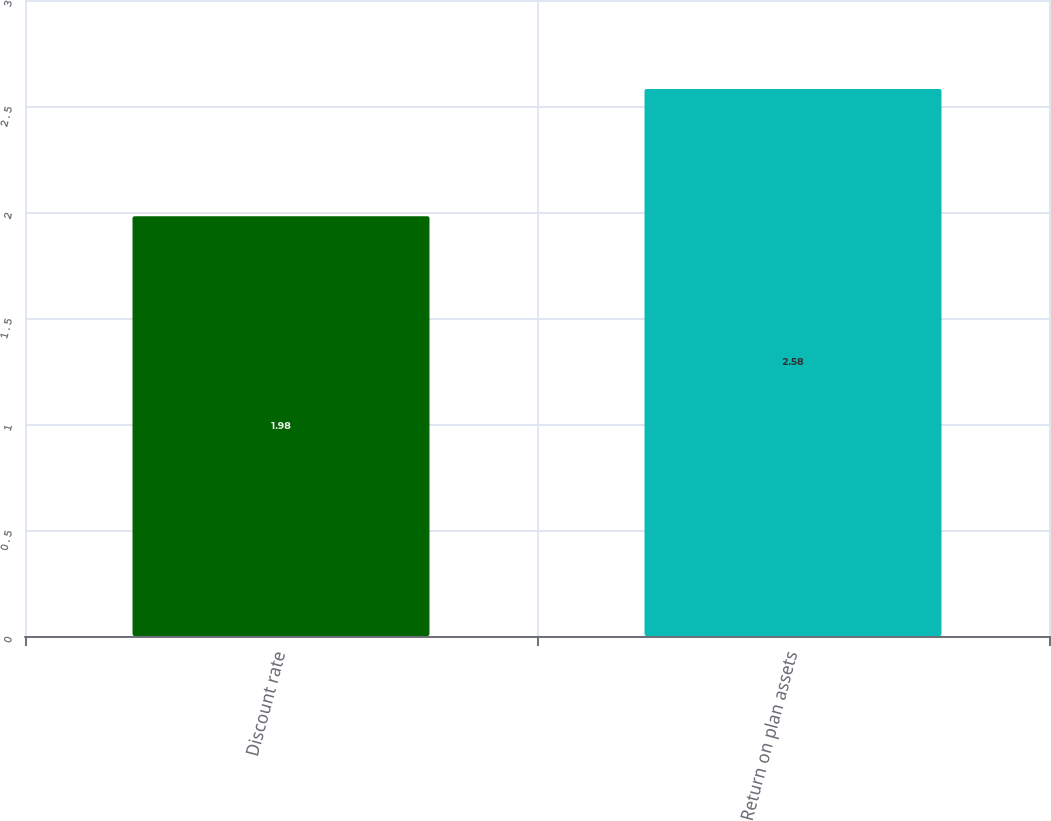<chart> <loc_0><loc_0><loc_500><loc_500><bar_chart><fcel>Discount rate<fcel>Return on plan assets<nl><fcel>1.98<fcel>2.58<nl></chart> 